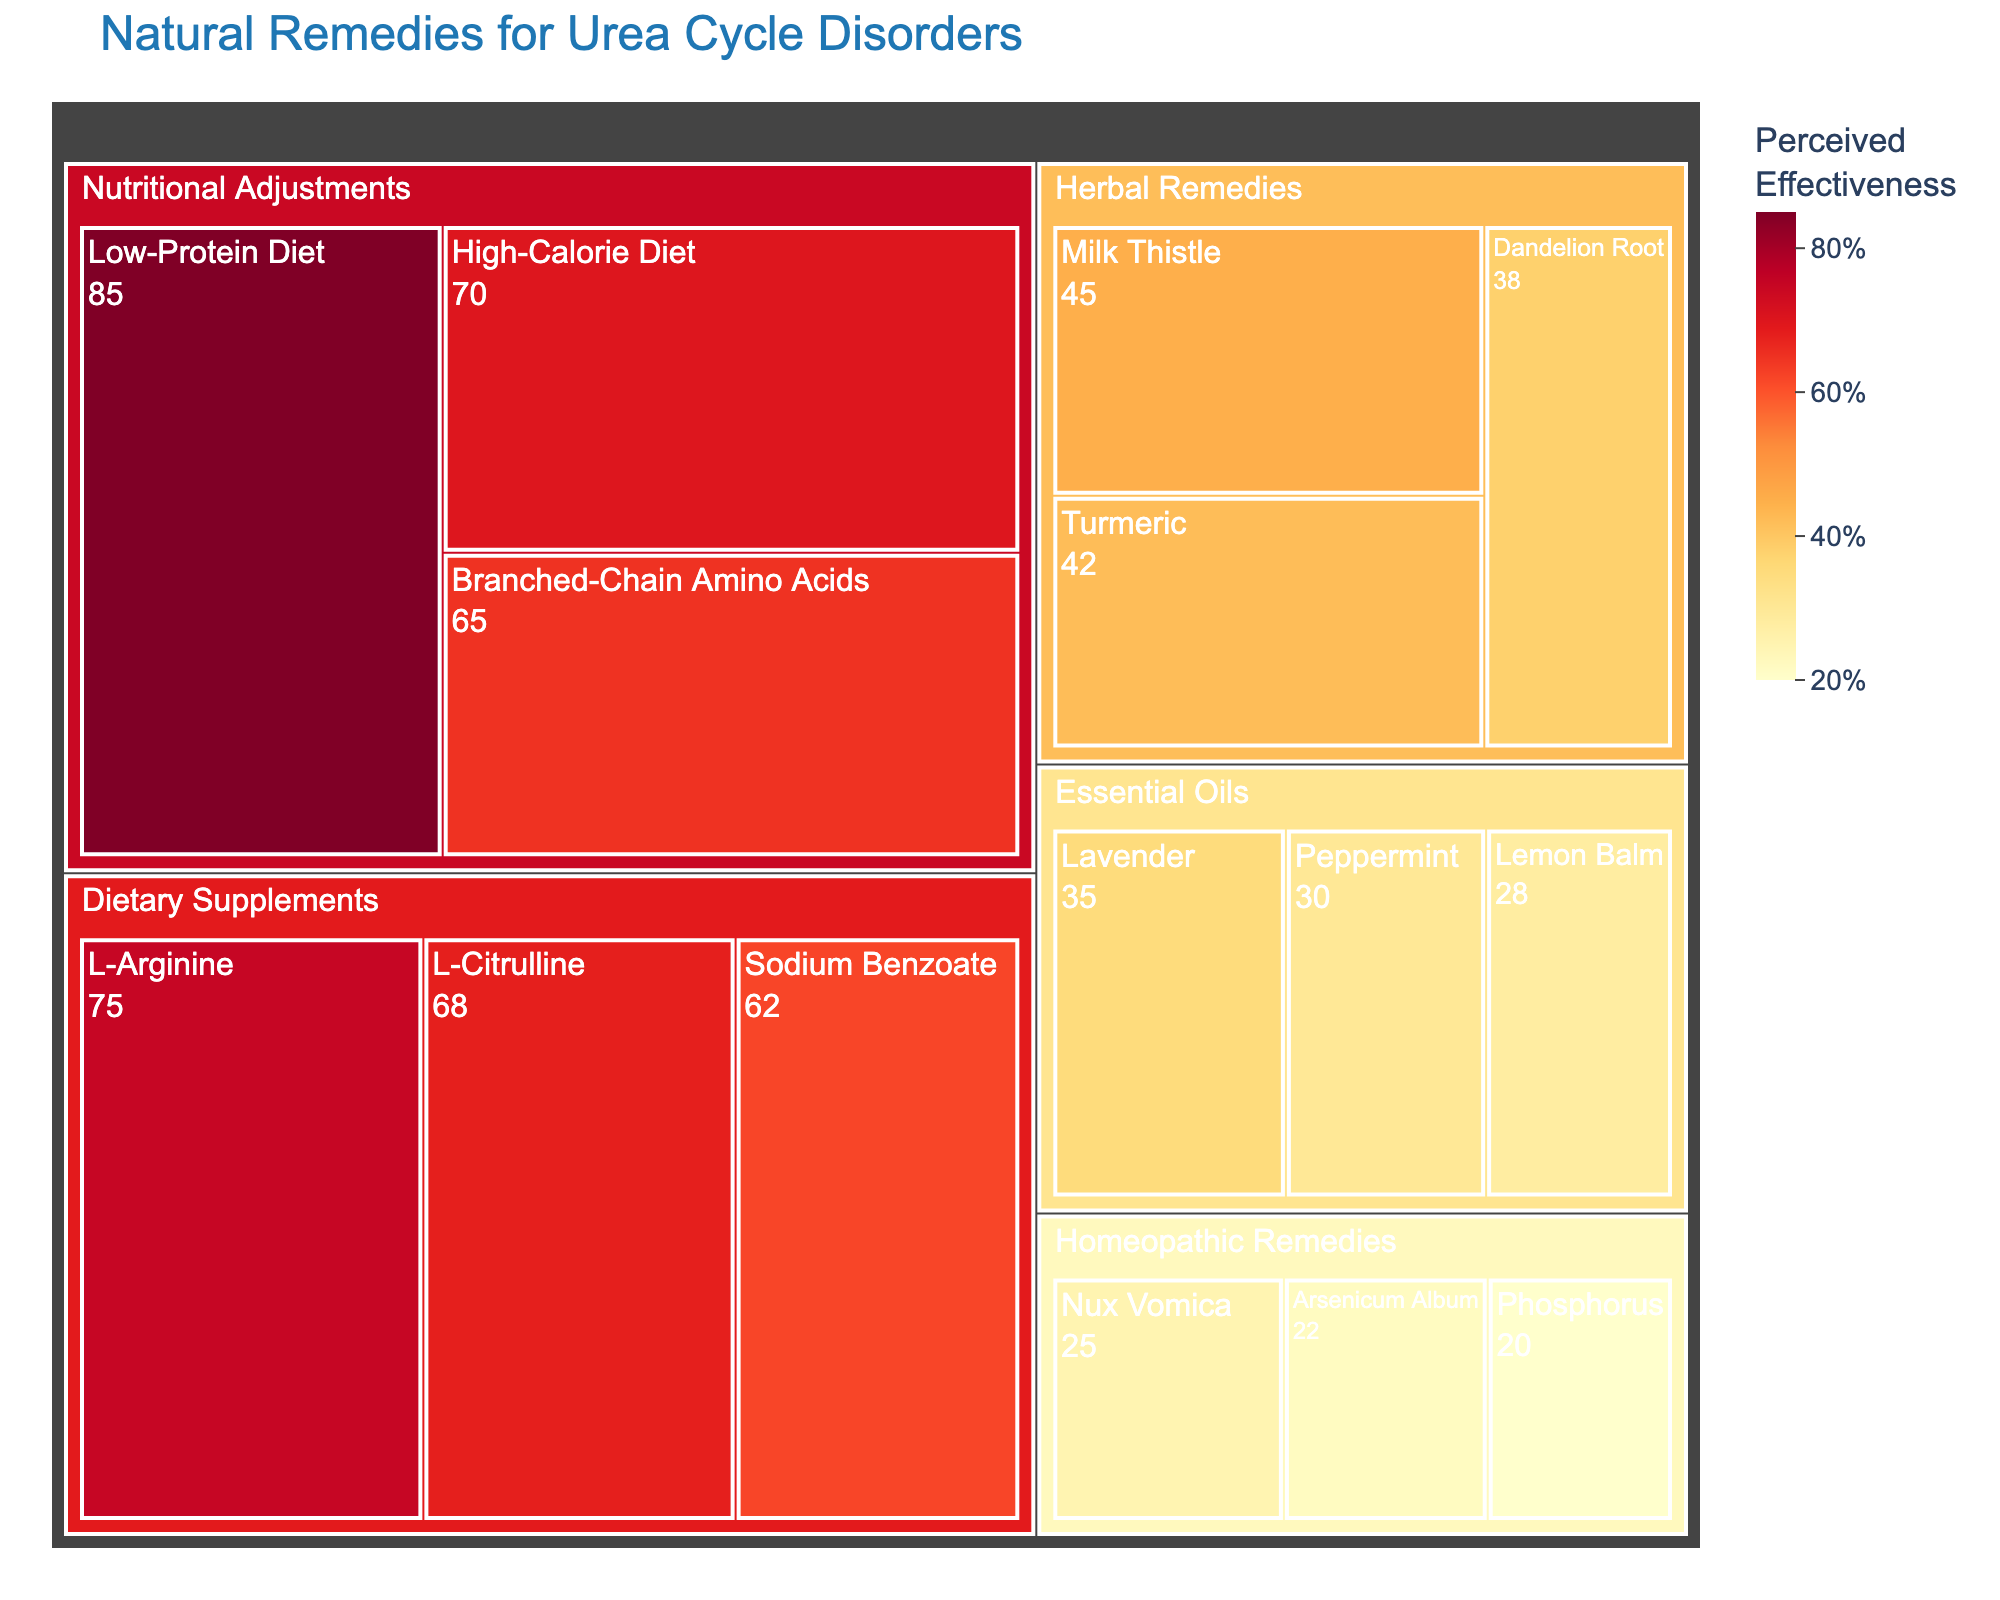what is the remedy with the highest perceived effectiveness? The remedy with the highest perceived effectiveness can be found within the "Nutritional Adjustments" category, which has the highest score. Look for the remedy labeled with 85%.
Answer: Low-Protein Diet which category has the lowest perceived effectiveness overall? Check the remedies in each category and find the one with the lowest score. Essential Oils have the lowest perceived effectiveness value of 28%.
Answer: Essential Oils what is the mean perceived effectiveness of dietary supplements? Sum the perceived effectiveness percentages of all dietary supplements and divide by the number of remedies. The sum is (75 + 68 + 62) = 205, divided by 3 is approximately 68.33%.
Answer: 68.33% which herbal remedy has the highest perceived effectiveness? In the "Herbal Remedies" category, find the remedy with the highest value. Milk Thistle has the highest perceived effectiveness of 45%.
Answer: Milk Thistle which remedy in nutritional adjustments has the lowest perceived effectiveness? In the "Nutritional Adjustments" category, find the remedy with the lowest value. Branched-Chain Amino Acids have the lowest effectiveness of 65%.
Answer: Branched-Chain Amino Acids compare the perceived effectiveness of lavender and milk thistle. Which is higher? Check the values for both remedies and compare them. Lavender has 35% and Milk Thistle has 45%, so Milk Thistle is higher.
Answer: Milk Thistle how many remedies have a perceived effectiveness above 50%? Count the remedies with perceived effectiveness values greater than 50%. There are 6 remedies (L-Arginine, L-Citrulline, Sodium Benzoate, Low-Protein Diet, High-Calorie Diet, Branched-Chain Amino Acids).
Answer: 6 what is the total perceived effectiveness of all remedies in essential oils? Add the perceived effectiveness percentages for all essential oils remedies. The sum is (35 + 30 + 28) = 93.
Answer: 93 what is the highest perceived effectiveness in homeopathic remedies? Check the perceived effectiveness values in the Homeopathic Remedies category and find the highest value. Nux Vomica has the highest at 25%.
Answer: Nux Vomica what is the difference in perceived effectiveness between the highest and lowest remedies in dietary supplements? Find the highest and lowest values in the Dietary Supplements category and calculate the difference. The highest is 75% (L-Arginine) and the lowest is 62% (Sodium Benzoate), so the difference is 75 - 62 = 13%.
Answer: 13% 